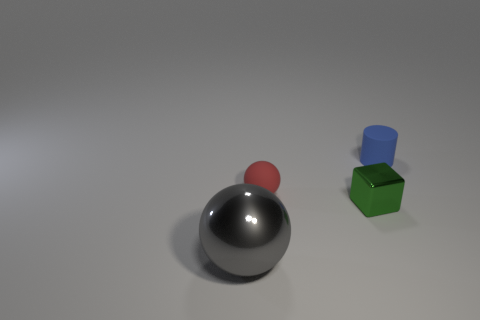Add 2 tiny yellow cylinders. How many objects exist? 6 Subtract all cylinders. How many objects are left? 3 Add 2 objects. How many objects are left? 6 Add 2 blue rubber things. How many blue rubber things exist? 3 Subtract 0 gray blocks. How many objects are left? 4 Subtract all tiny red spheres. Subtract all big shiny spheres. How many objects are left? 2 